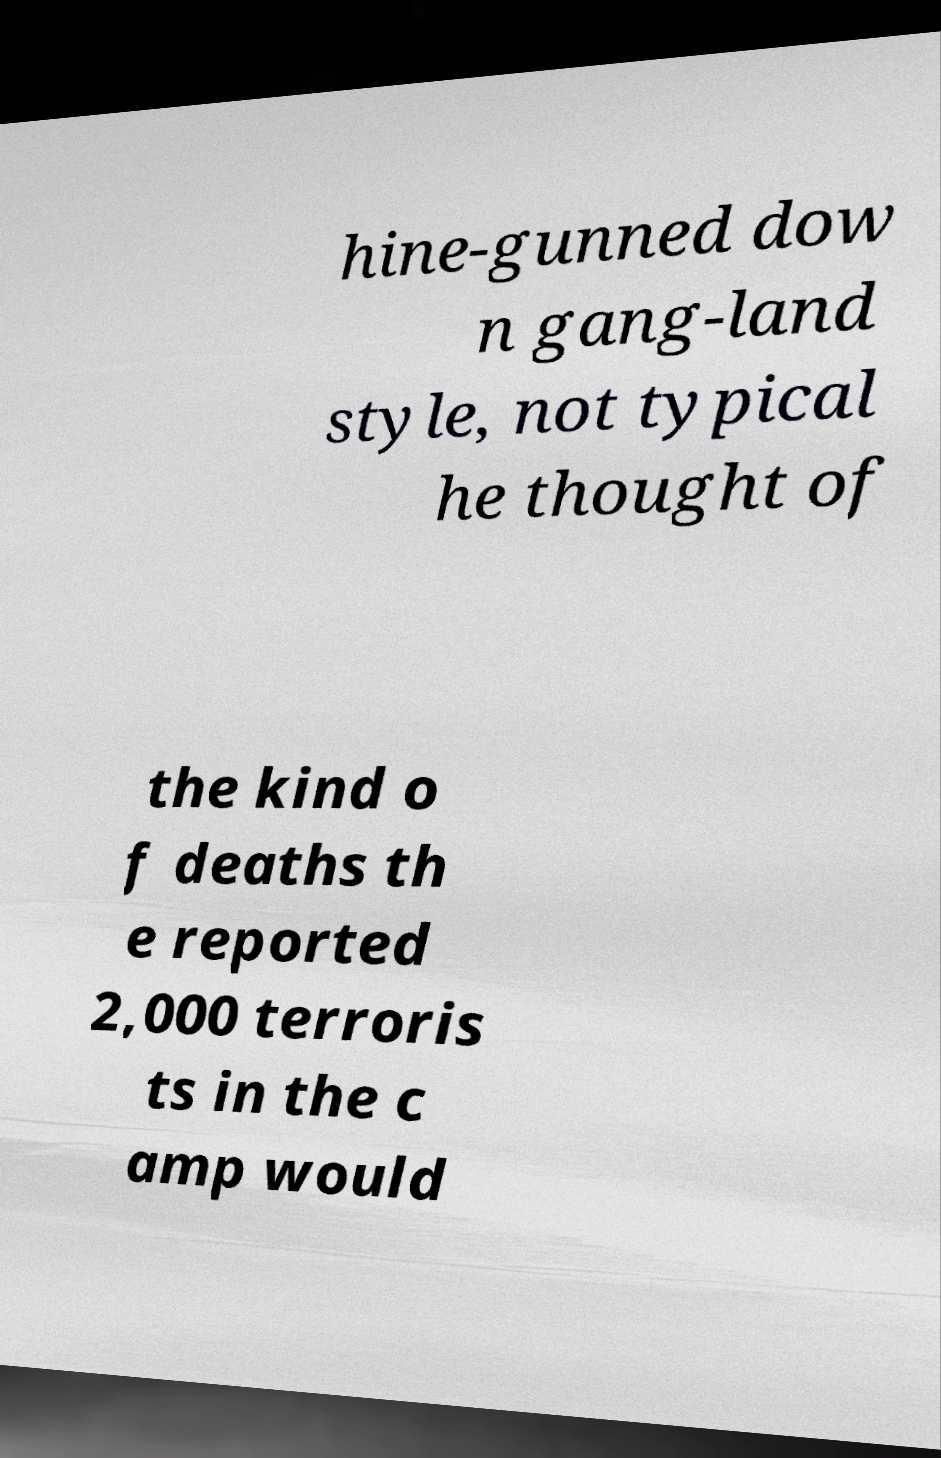Please identify and transcribe the text found in this image. hine-gunned dow n gang-land style, not typical he thought of the kind o f deaths th e reported 2,000 terroris ts in the c amp would 